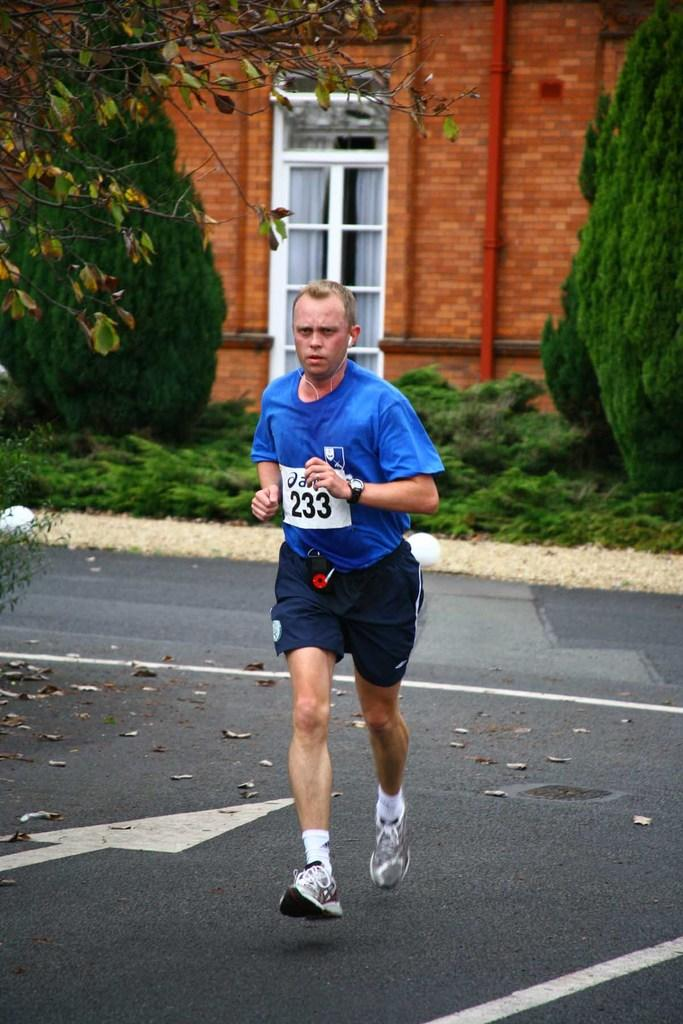<image>
Offer a succinct explanation of the picture presented. A man with the number 233 runs a race. 